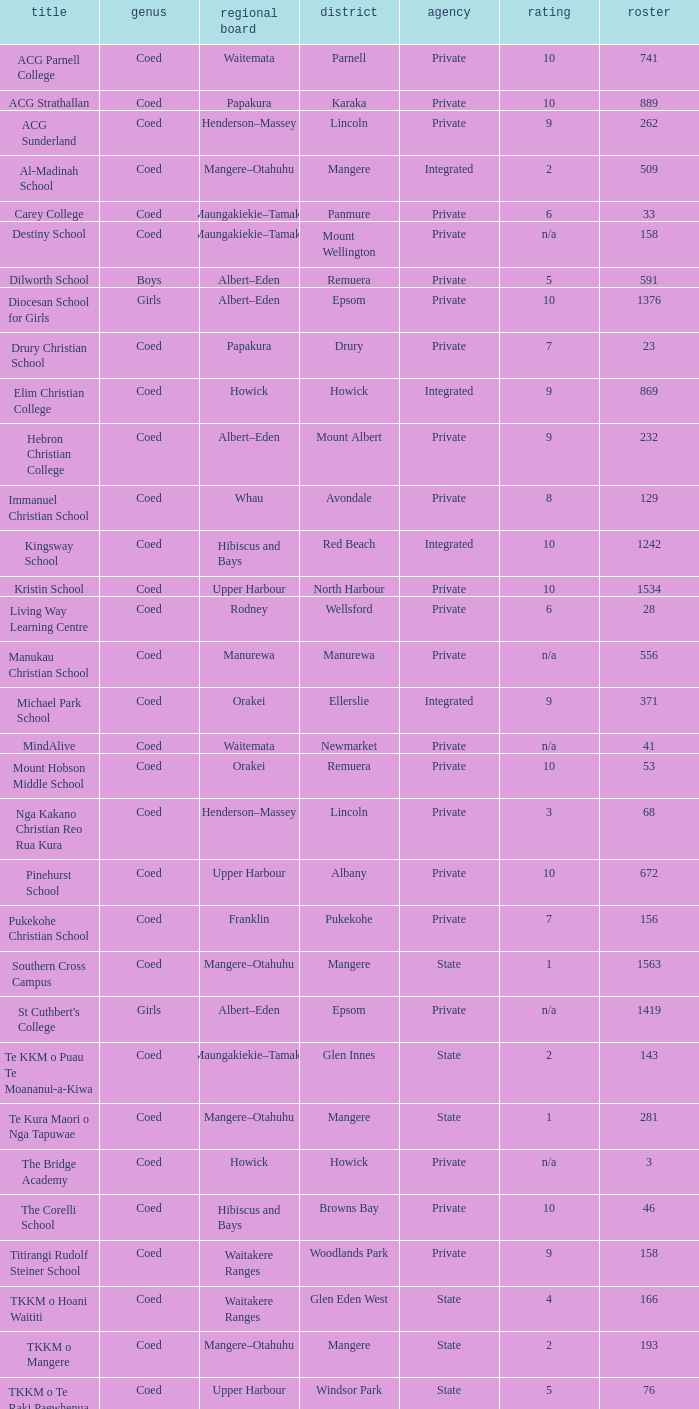What is the name of the suburb with a roll of 741? Parnell. 